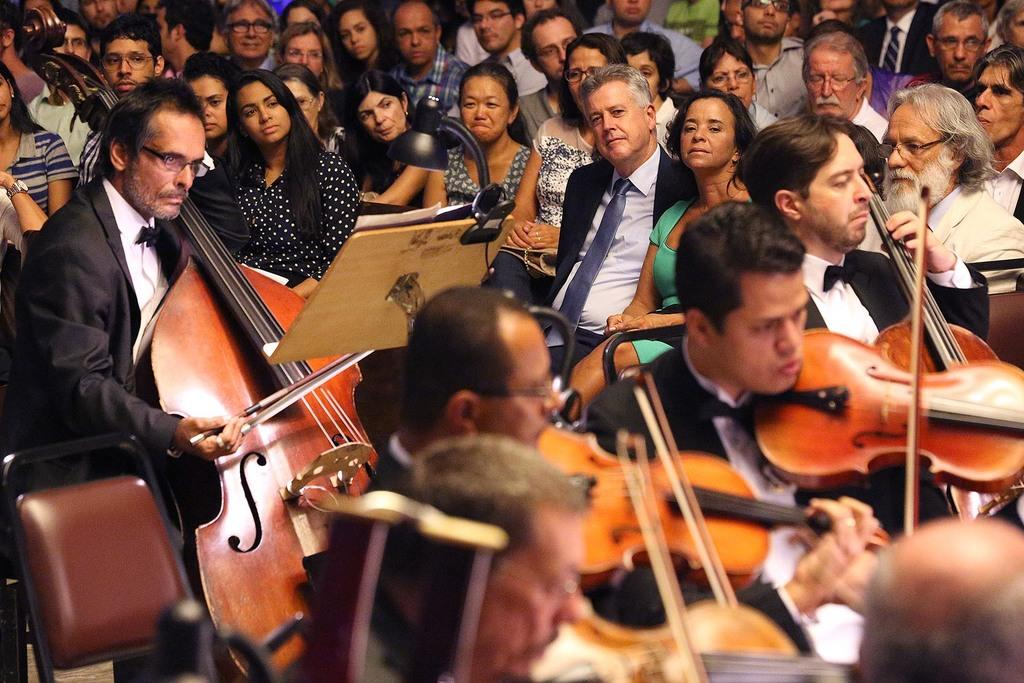What are the people in the image doing? The people in the image are sitting. What are some of the people holding? Some people are holding musical instruments. Can you describe any furniture in the image? Yes, there is a chair in the image. What else can be seen in the image besides people and furniture? There is a lamp in the image. What type of beam is supporting the roof in the image? There is no roof or beam present in the image; it only shows people sitting, some holding musical instruments, a chair, and a lamp. 